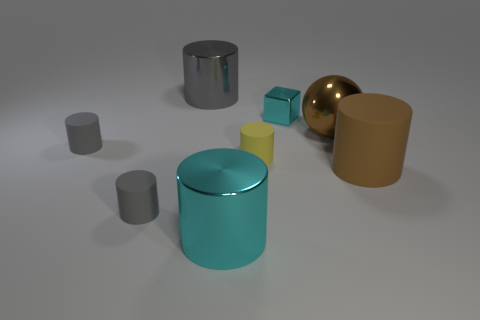This scene looks artificially created; can you tell me more about its potential function or purpose? The scene indeed has the appearance of a 3D rendering or digital illustration. The arrangement of objects could serve as a visual exercise in understanding spatial relationships, shading, and texture in a virtual environment. The objects' varying materials, reflected in their surfaces, might also be used to demonstrate rendering techniques for matte and shiny textures in computer graphics education or software testing. 